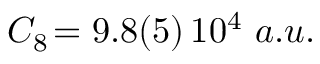Convert formula to latex. <formula><loc_0><loc_0><loc_500><loc_500>C _ { 8 } \, = 9 . 8 ( 5 ) \, 1 0 ^ { 4 } a . u .</formula> 